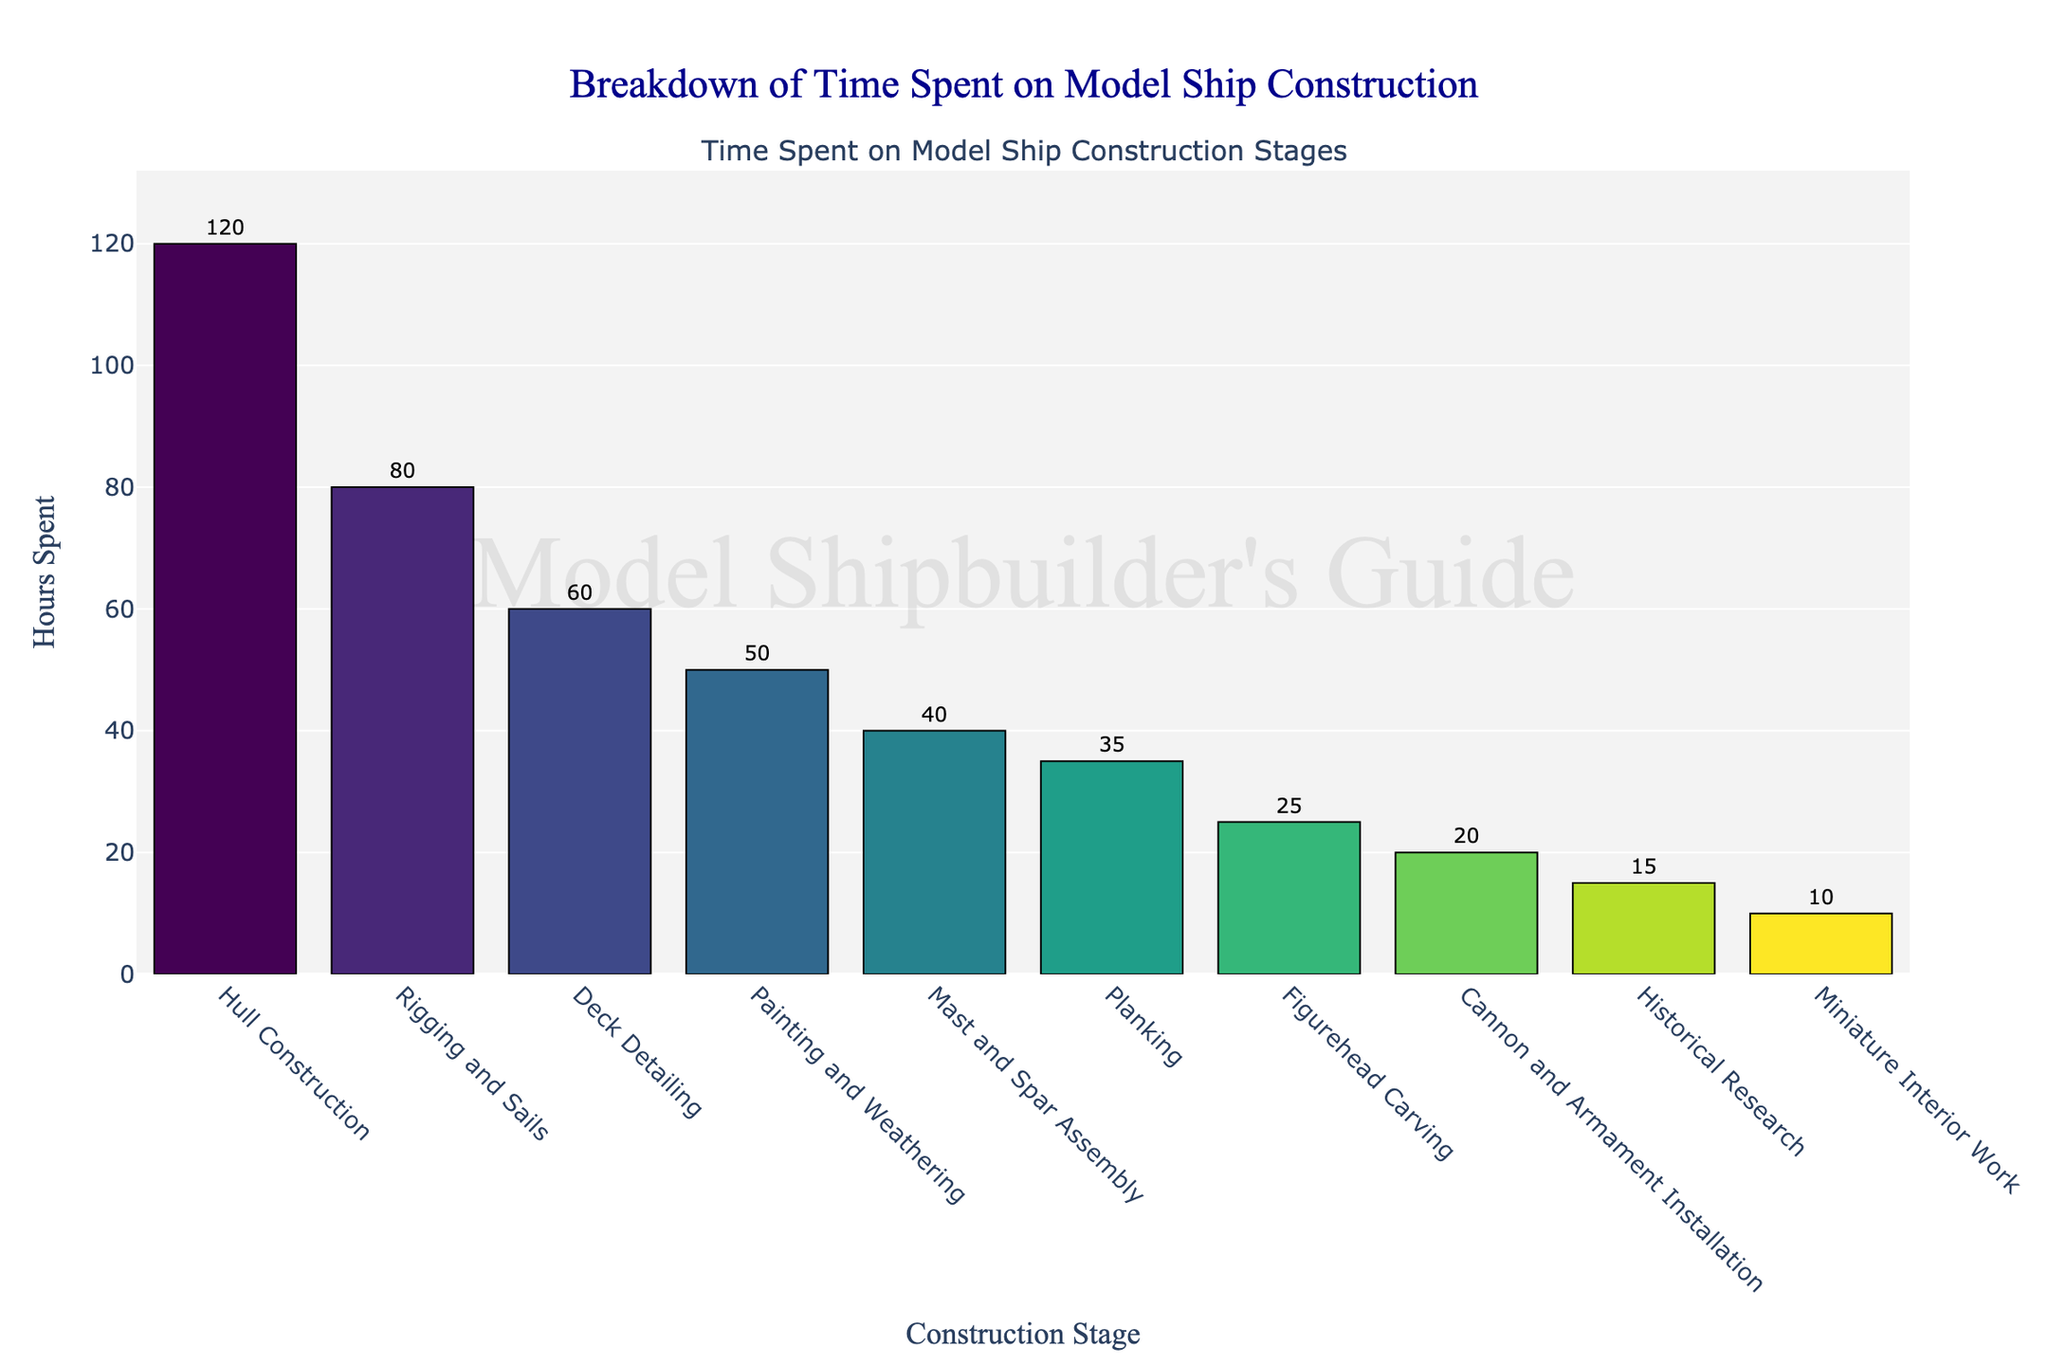Which stage requires the most hours? The highest bar represents the stage with the most hours. According to the figure, Hull Construction has the tallest bar.
Answer: Hull Construction Which stage requires the least hours? The shortest bar represents the stage with the least hours. According to the figure, Miniature Interior Work has the shortest bar.
Answer: Miniature Interior Work How many more hours does Hull Construction take compared to Mast and Spar Assembly? Hull Construction takes 120 hours, and Mast and Spar Assembly takes 40 hours. The difference is 120 - 40.
Answer: 80 What is the total time spent on historical research and figurehead carving? Historical Research takes 15 hours, and Figurehead Carving takes 25 hours. Summing them up, we get 15 + 25.
Answer: 40 How does the time spent on Painting and Weathering compare to Deck Detailing? Painting and Weathering takes 50 hours, while Deck Detailing takes 60 hours. Comparing these two values, Painting and Weathering takes 10 hours less than Deck Detailing.
Answer: 10 hours less Which stages take more than 50 hours? Stages with bars higher than the 50-hour mark are Hull Construction, Rigging and Sails, and Deck Detailing.
Answer: Hull Construction, Rigging and Sails, Deck Detailing What is the combined time for Rigging and Sails, and Planking? Rigging and Sails takes 80 hours, and Planking takes 35 hours. Summing them up, we get 80 + 35.
Answer: 115 How much time is spent on Deck Detailing and Cannon and Armament Installation combined? Deck Detailing takes 60 hours, and Cannon and Armament Installation takes 20 hours. Summing them up, we get 60 + 20.
Answer: 80 Which stage comes third in the total hours spent? By looking at the third tallest bar, Deck Detailing comes third in total hours spent.
Answer: Deck Detailing Is more time spent on Rigging and Sails than Painting and Weathering? How much more? Rigging and Sails takes 80 hours, and Painting and Weathering takes 50 hours. The difference is 80 - 50.
Answer: 30 hours more 